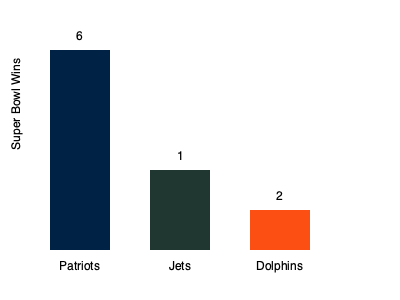Based on the bar chart comparing Super Bowl wins, how many more Super Bowl victories do the New England Patriots have compared to the combined total of their division rivals, the Jets and Dolphins? To solve this question, we need to follow these steps:

1. Identify the number of Super Bowl wins for each team:
   - Patriots: 6 wins
   - Jets: 1 win
   - Dolphins: 2 wins

2. Calculate the combined total of Jets and Dolphins wins:
   $1 + 2 = 3$ wins

3. Subtract the combined total from the Patriots' wins:
   $6 - 3 = 3$ wins

Therefore, the New England Patriots have 3 more Super Bowl victories than the combined total of their division rivals, the Jets and Dolphins.
Answer: 3 